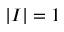Convert formula to latex. <formula><loc_0><loc_0><loc_500><loc_500>\left | I \right | = 1</formula> 